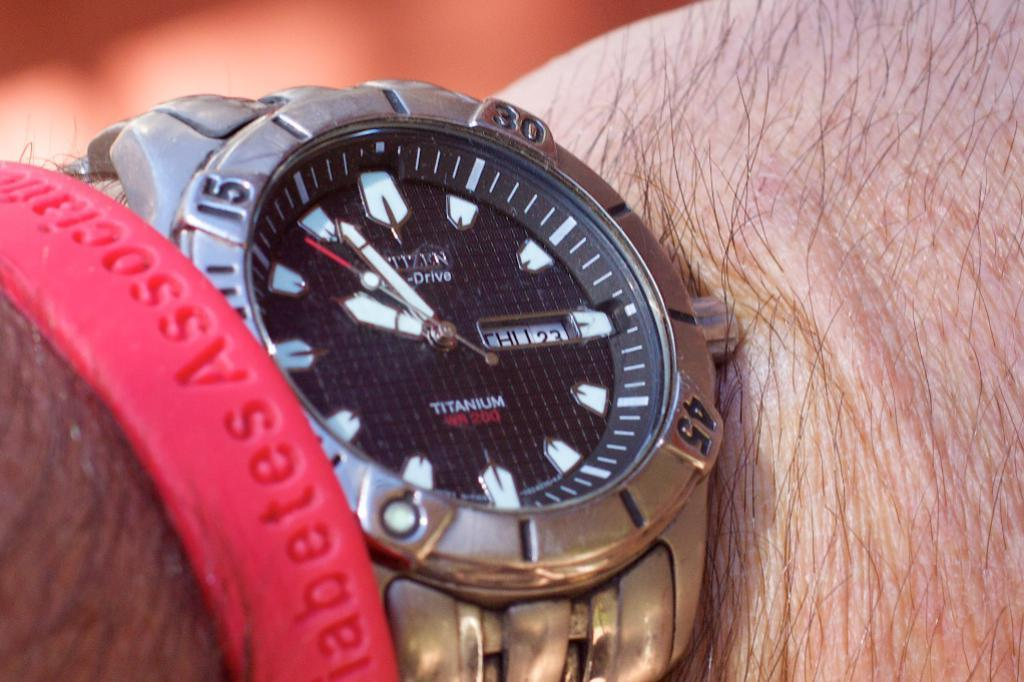<image>
Relay a brief, clear account of the picture shown. A men's watch that is made of titanium. 